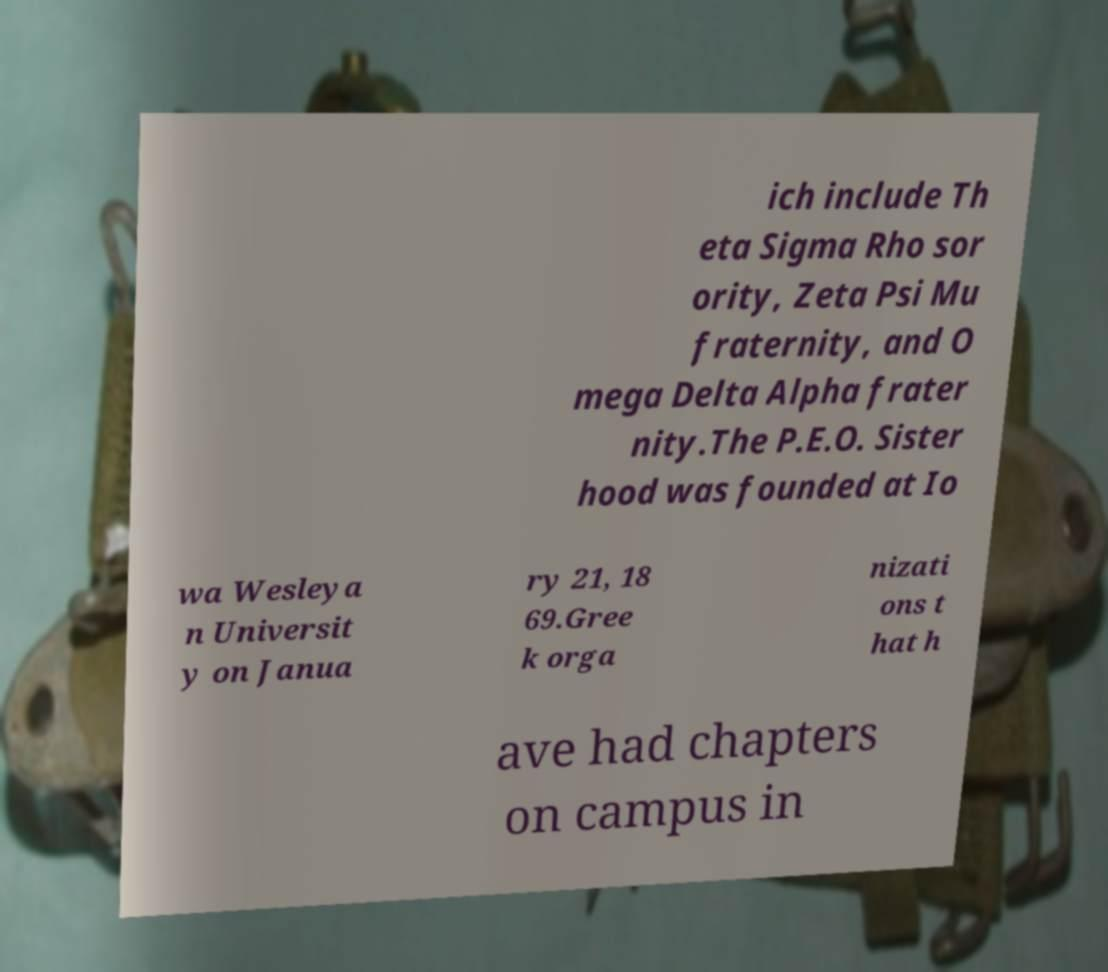Could you extract and type out the text from this image? ich include Th eta Sigma Rho sor ority, Zeta Psi Mu fraternity, and O mega Delta Alpha frater nity.The P.E.O. Sister hood was founded at Io wa Wesleya n Universit y on Janua ry 21, 18 69.Gree k orga nizati ons t hat h ave had chapters on campus in 